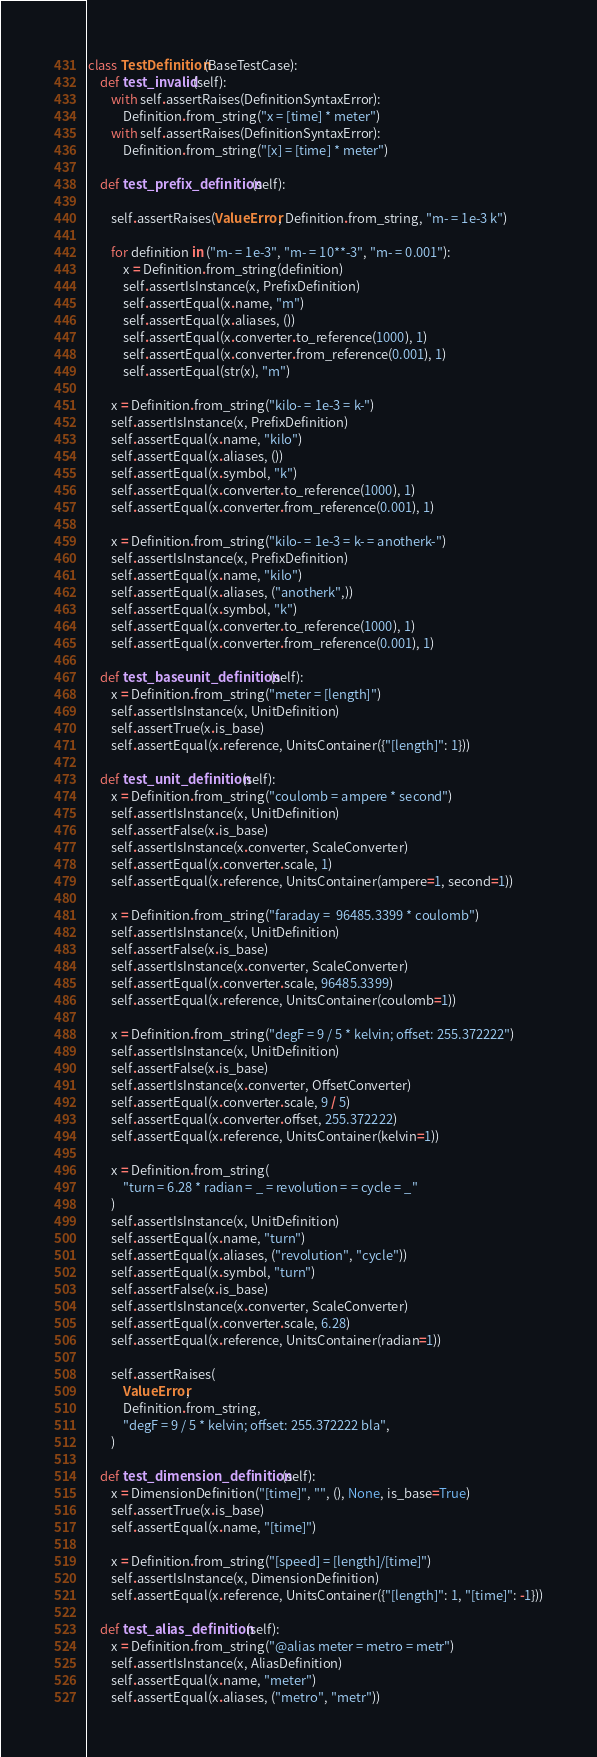<code> <loc_0><loc_0><loc_500><loc_500><_Python_>
class TestDefinition(BaseTestCase):
    def test_invalid(self):
        with self.assertRaises(DefinitionSyntaxError):
            Definition.from_string("x = [time] * meter")
        with self.assertRaises(DefinitionSyntaxError):
            Definition.from_string("[x] = [time] * meter")

    def test_prefix_definition(self):

        self.assertRaises(ValueError, Definition.from_string, "m- = 1e-3 k")

        for definition in ("m- = 1e-3", "m- = 10**-3", "m- = 0.001"):
            x = Definition.from_string(definition)
            self.assertIsInstance(x, PrefixDefinition)
            self.assertEqual(x.name, "m")
            self.assertEqual(x.aliases, ())
            self.assertEqual(x.converter.to_reference(1000), 1)
            self.assertEqual(x.converter.from_reference(0.001), 1)
            self.assertEqual(str(x), "m")

        x = Definition.from_string("kilo- = 1e-3 = k-")
        self.assertIsInstance(x, PrefixDefinition)
        self.assertEqual(x.name, "kilo")
        self.assertEqual(x.aliases, ())
        self.assertEqual(x.symbol, "k")
        self.assertEqual(x.converter.to_reference(1000), 1)
        self.assertEqual(x.converter.from_reference(0.001), 1)

        x = Definition.from_string("kilo- = 1e-3 = k- = anotherk-")
        self.assertIsInstance(x, PrefixDefinition)
        self.assertEqual(x.name, "kilo")
        self.assertEqual(x.aliases, ("anotherk",))
        self.assertEqual(x.symbol, "k")
        self.assertEqual(x.converter.to_reference(1000), 1)
        self.assertEqual(x.converter.from_reference(0.001), 1)

    def test_baseunit_definition(self):
        x = Definition.from_string("meter = [length]")
        self.assertIsInstance(x, UnitDefinition)
        self.assertTrue(x.is_base)
        self.assertEqual(x.reference, UnitsContainer({"[length]": 1}))

    def test_unit_definition(self):
        x = Definition.from_string("coulomb = ampere * second")
        self.assertIsInstance(x, UnitDefinition)
        self.assertFalse(x.is_base)
        self.assertIsInstance(x.converter, ScaleConverter)
        self.assertEqual(x.converter.scale, 1)
        self.assertEqual(x.reference, UnitsContainer(ampere=1, second=1))

        x = Definition.from_string("faraday =  96485.3399 * coulomb")
        self.assertIsInstance(x, UnitDefinition)
        self.assertFalse(x.is_base)
        self.assertIsInstance(x.converter, ScaleConverter)
        self.assertEqual(x.converter.scale, 96485.3399)
        self.assertEqual(x.reference, UnitsContainer(coulomb=1))

        x = Definition.from_string("degF = 9 / 5 * kelvin; offset: 255.372222")
        self.assertIsInstance(x, UnitDefinition)
        self.assertFalse(x.is_base)
        self.assertIsInstance(x.converter, OffsetConverter)
        self.assertEqual(x.converter.scale, 9 / 5)
        self.assertEqual(x.converter.offset, 255.372222)
        self.assertEqual(x.reference, UnitsContainer(kelvin=1))

        x = Definition.from_string(
            "turn = 6.28 * radian = _ = revolution = = cycle = _"
        )
        self.assertIsInstance(x, UnitDefinition)
        self.assertEqual(x.name, "turn")
        self.assertEqual(x.aliases, ("revolution", "cycle"))
        self.assertEqual(x.symbol, "turn")
        self.assertFalse(x.is_base)
        self.assertIsInstance(x.converter, ScaleConverter)
        self.assertEqual(x.converter.scale, 6.28)
        self.assertEqual(x.reference, UnitsContainer(radian=1))

        self.assertRaises(
            ValueError,
            Definition.from_string,
            "degF = 9 / 5 * kelvin; offset: 255.372222 bla",
        )

    def test_dimension_definition(self):
        x = DimensionDefinition("[time]", "", (), None, is_base=True)
        self.assertTrue(x.is_base)
        self.assertEqual(x.name, "[time]")

        x = Definition.from_string("[speed] = [length]/[time]")
        self.assertIsInstance(x, DimensionDefinition)
        self.assertEqual(x.reference, UnitsContainer({"[length]": 1, "[time]": -1}))

    def test_alias_definition(self):
        x = Definition.from_string("@alias meter = metro = metr")
        self.assertIsInstance(x, AliasDefinition)
        self.assertEqual(x.name, "meter")
        self.assertEqual(x.aliases, ("metro", "metr"))
</code> 